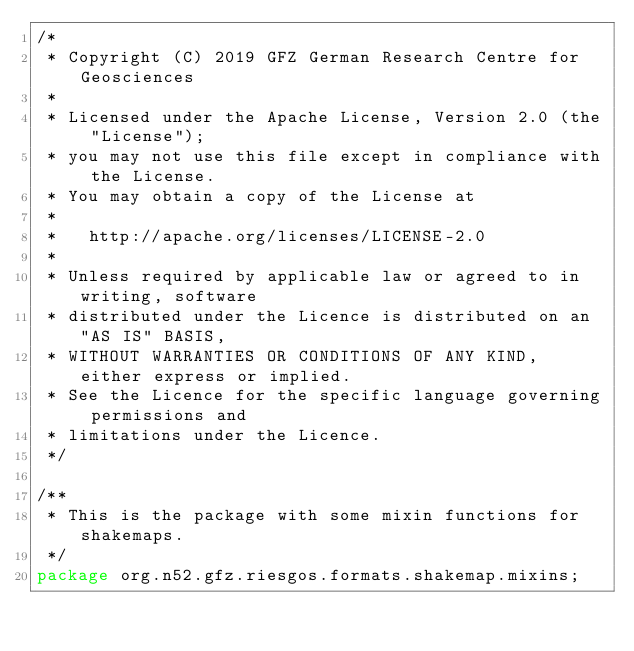<code> <loc_0><loc_0><loc_500><loc_500><_Java_>/*
 * Copyright (C) 2019 GFZ German Research Centre for Geosciences
 *
 * Licensed under the Apache License, Version 2.0 (the "License");
 * you may not use this file except in compliance with the License.
 * You may obtain a copy of the License at
 *
 *   http://apache.org/licenses/LICENSE-2.0
 *
 * Unless required by applicable law or agreed to in writing, software
 * distributed under the Licence is distributed on an "AS IS" BASIS,
 * WITHOUT WARRANTIES OR CONDITIONS OF ANY KIND, either express or implied.
 * See the Licence for the specific language governing permissions and
 * limitations under the Licence.
 */

/**
 * This is the package with some mixin functions for shakemaps.
 */
package org.n52.gfz.riesgos.formats.shakemap.mixins;
</code> 